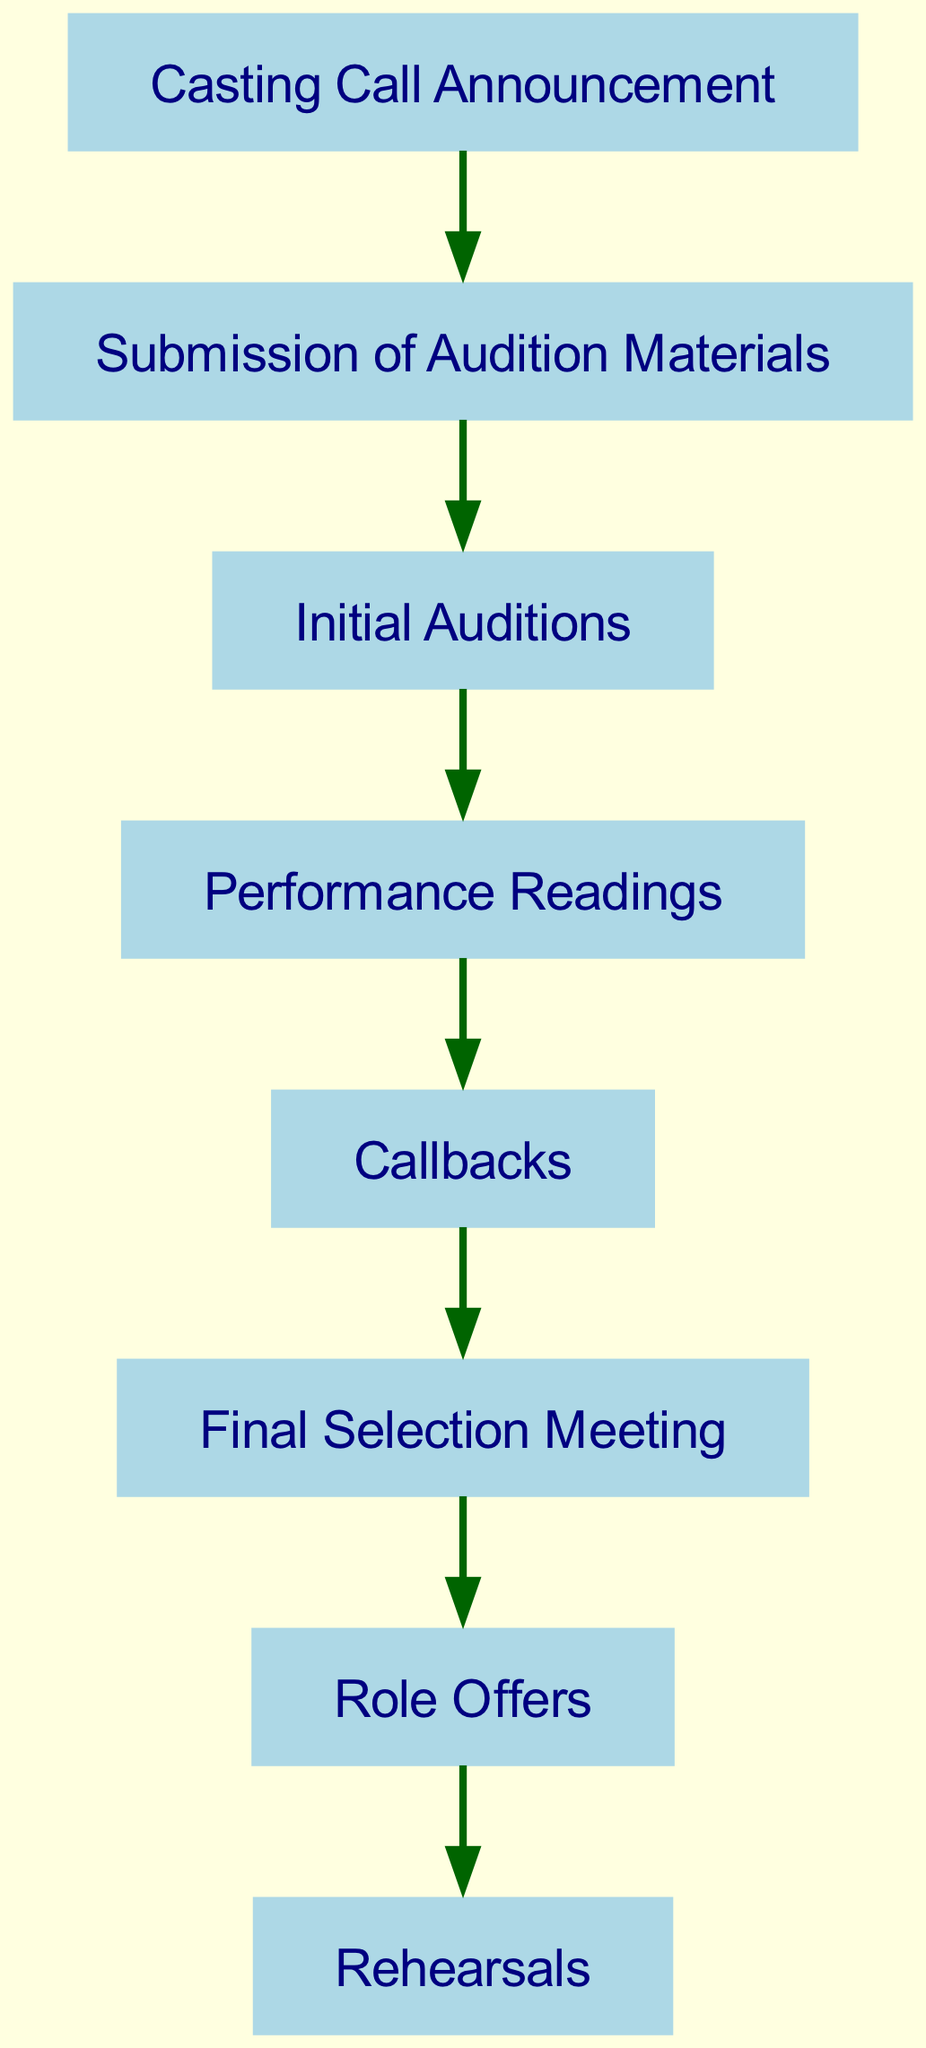What is the first step in the casting process? The first step is the "Casting Call Announcement." This is indicated as the starting node in the directed graph, showing it as the beginning of the process.
Answer: Casting Call Announcement How many nodes are present in the diagram? The diagram contains a total of eight nodes, representing different stages of the casting process. This can be counted by reviewing the list of nodes provided in the data.
Answer: 8 Which node follows "Initial Auditions"? The node that follows "Initial Auditions" is "Performance Readings." This is determined by tracing the directed edge from the "Initial Auditions" node to the next connected node.
Answer: Performance Readings What is the last step of the casting process? The last step is labeled "Rehearsals," which is indicated as the final node in the sequence of the directed graph. This node has no outgoing edges, showing that it concludes the process.
Answer: Rehearsals How many edges are there in the diagram? There are seven edges in the diagram, which can be confirmed by counting the relationships that connect the nodes. Each edge represents a directed flow from one step to the next.
Answer: 7 What connects "Callbacks" to "Final Selection Meeting"? The edge that connects "Callbacks" to "Final Selection Meeting" represents the directed transition from the callbacks stage to the final selection. This specific relationship is illustrated in the edges listed in the data.
Answer: Final Selection Meeting Which node has an outgoing edge to "Role Offers"? The node with an outgoing edge to "Role Offers" is "Final Selection Meeting." This can be identified by looking at the edges where "6" (Final Selection Meeting) points to "7" (Role Offers) in the directed graph.
Answer: Final Selection Meeting Where does the "Submission of Audition Materials" lead to? The "Submission of Audition Materials" leads to "Initial Auditions." This progression is indicated by the directed edge connecting these two specific nodes in the diagram.
Answer: Initial Auditions 